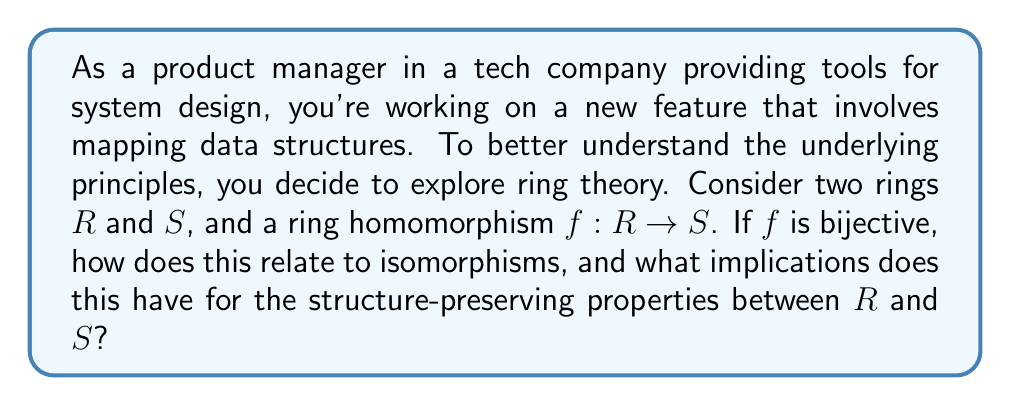Solve this math problem. Let's break this down step-by-step:

1) First, recall the definitions:
   - A ring homomorphism $f: R \rightarrow S$ is a function that preserves both addition and multiplication:
     $f(a+b) = f(a) + f(b)$ and $f(ab) = f(a)f(b)$ for all $a,b \in R$

   - An isomorphism is a bijective homomorphism.

2) Given that $f$ is a ring homomorphism and bijective, we can conclude that $f$ is an isomorphism.

3) The bijective property of $f$ means:
   - It's injective (one-to-one): $f(a) = f(b)$ implies $a = b$
   - It's surjective (onto): For every $s \in S$, there exists an $r \in R$ such that $f(r) = s$

4) The implications of $f$ being an isomorphism are significant:

   a) It preserves the ring structure perfectly. This means:
      - The additive structures of $R$ and $S$ are identical.
      - The multiplicative structures of $R$ and $S$ are identical.

   b) There exists an inverse function $f^{-1}: S \rightarrow R$ that is also a ring isomorphism.

   c) $R$ and $S$ are essentially the same ring, just with potentially different labels for their elements.

5) In the context of system design, this implies that data structures or systems modeled by isomorphic rings will have identical algebraic properties, allowing for seamless translation between them while preserving all structural relationships.

6) Some specific preserved properties include:
   - If $R$ is commutative, then $S$ is commutative.
   - If $R$ has an identity element, then $S$ has an identity element.
   - The characteristic of $R$ equals the characteristic of $S$.
   - $R$ is a field if and only if $S$ is a field.

This relationship between homomorphisms and isomorphisms demonstrates that while homomorphisms preserve structure in a general sense, isomorphisms preserve structure perfectly, allowing for a one-to-one correspondence between all elements and operations in the two rings.
Answer: A bijective ring homomorphism is an isomorphism, implying that the rings $R$ and $S$ have identical algebraic structures. This means all ring-theoretic properties are preserved, and there exists an inverse isomorphism $f^{-1}: S \rightarrow R$, allowing for perfect translation between the two rings while maintaining all structural relationships. 